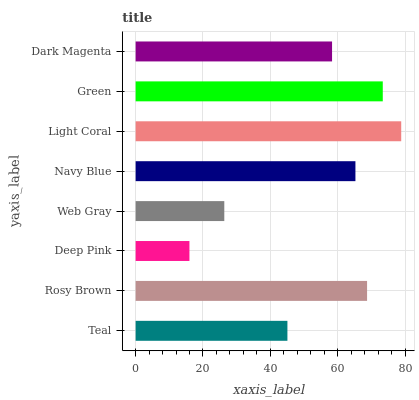Is Deep Pink the minimum?
Answer yes or no. Yes. Is Light Coral the maximum?
Answer yes or no. Yes. Is Rosy Brown the minimum?
Answer yes or no. No. Is Rosy Brown the maximum?
Answer yes or no. No. Is Rosy Brown greater than Teal?
Answer yes or no. Yes. Is Teal less than Rosy Brown?
Answer yes or no. Yes. Is Teal greater than Rosy Brown?
Answer yes or no. No. Is Rosy Brown less than Teal?
Answer yes or no. No. Is Navy Blue the high median?
Answer yes or no. Yes. Is Dark Magenta the low median?
Answer yes or no. Yes. Is Rosy Brown the high median?
Answer yes or no. No. Is Rosy Brown the low median?
Answer yes or no. No. 